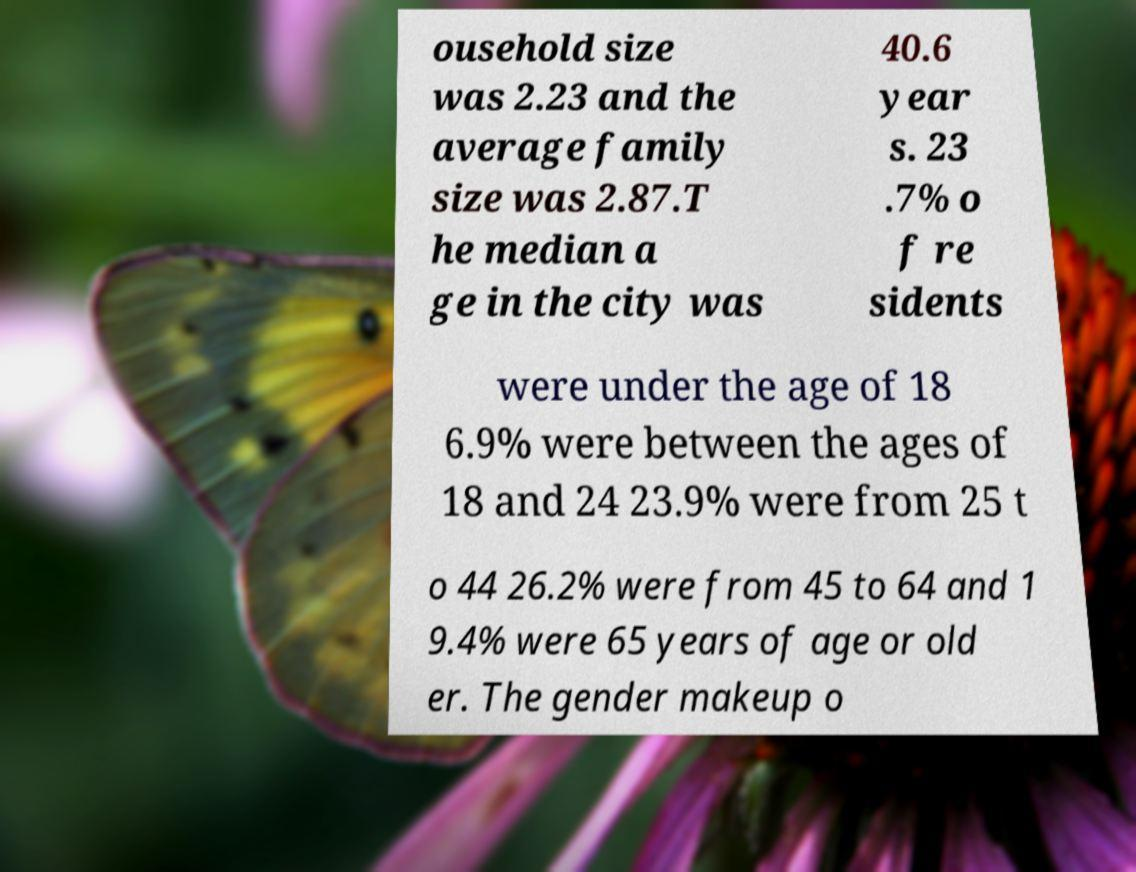There's text embedded in this image that I need extracted. Can you transcribe it verbatim? ousehold size was 2.23 and the average family size was 2.87.T he median a ge in the city was 40.6 year s. 23 .7% o f re sidents were under the age of 18 6.9% were between the ages of 18 and 24 23.9% were from 25 t o 44 26.2% were from 45 to 64 and 1 9.4% were 65 years of age or old er. The gender makeup o 